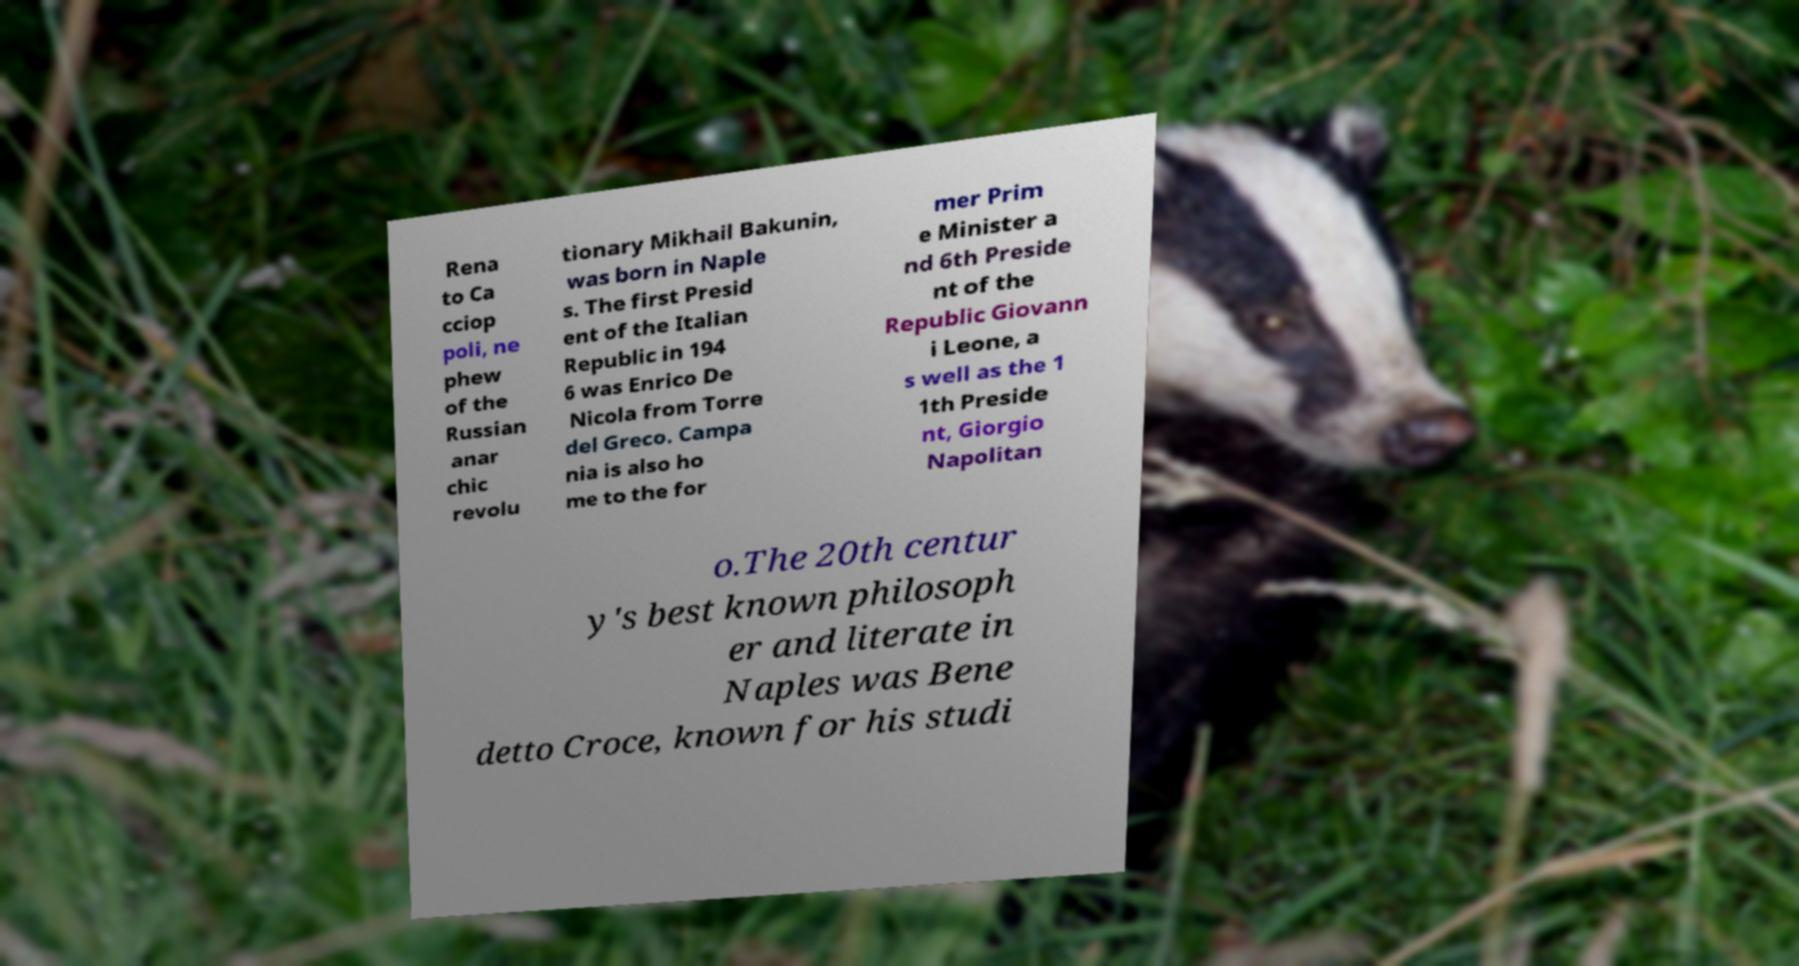What messages or text are displayed in this image? I need them in a readable, typed format. Rena to Ca cciop poli, ne phew of the Russian anar chic revolu tionary Mikhail Bakunin, was born in Naple s. The first Presid ent of the Italian Republic in 194 6 was Enrico De Nicola from Torre del Greco. Campa nia is also ho me to the for mer Prim e Minister a nd 6th Preside nt of the Republic Giovann i Leone, a s well as the 1 1th Preside nt, Giorgio Napolitan o.The 20th centur y's best known philosoph er and literate in Naples was Bene detto Croce, known for his studi 